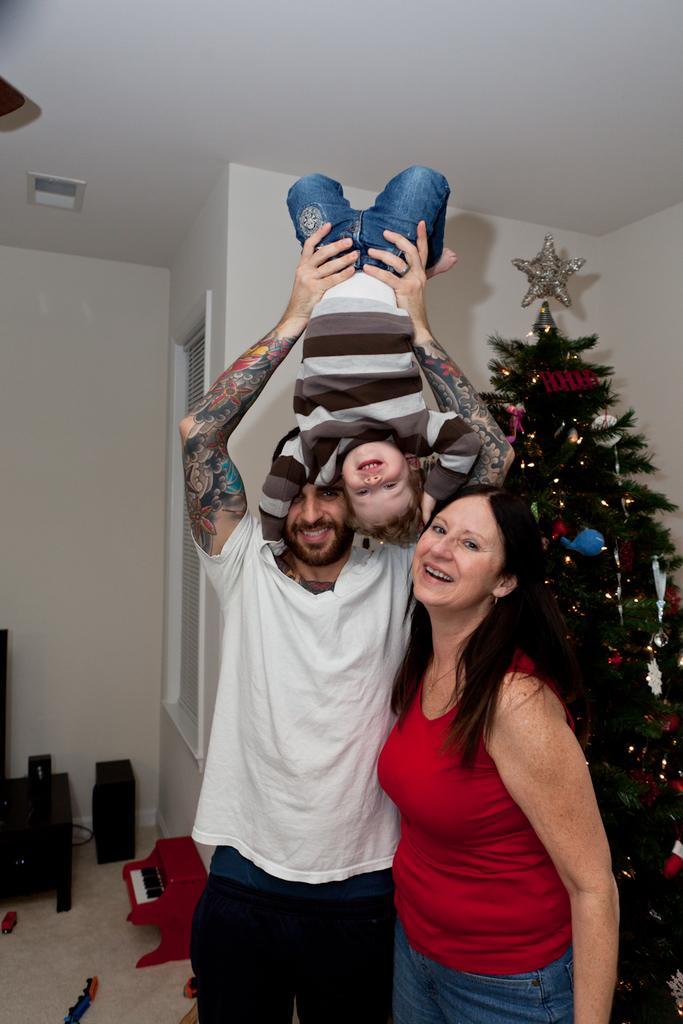Please provide a concise description of this image. In this image a person wearing a white shirt is holding a baby. Beside him there is a woman wearing a red top. Behind them there is a Christmas tree. On it there is a star and few decorative item on it. Left side there is a table, beside there is a device and a musical toy near the wall. There is a window to the wall. 